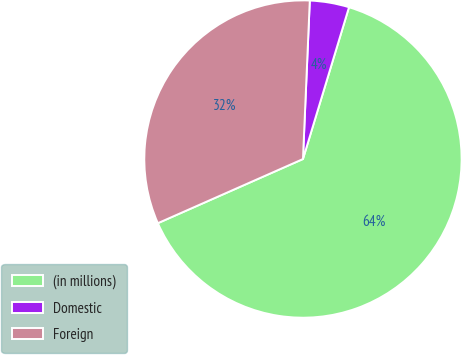Convert chart to OTSL. <chart><loc_0><loc_0><loc_500><loc_500><pie_chart><fcel>(in millions)<fcel>Domestic<fcel>Foreign<nl><fcel>63.69%<fcel>4.0%<fcel>32.31%<nl></chart> 